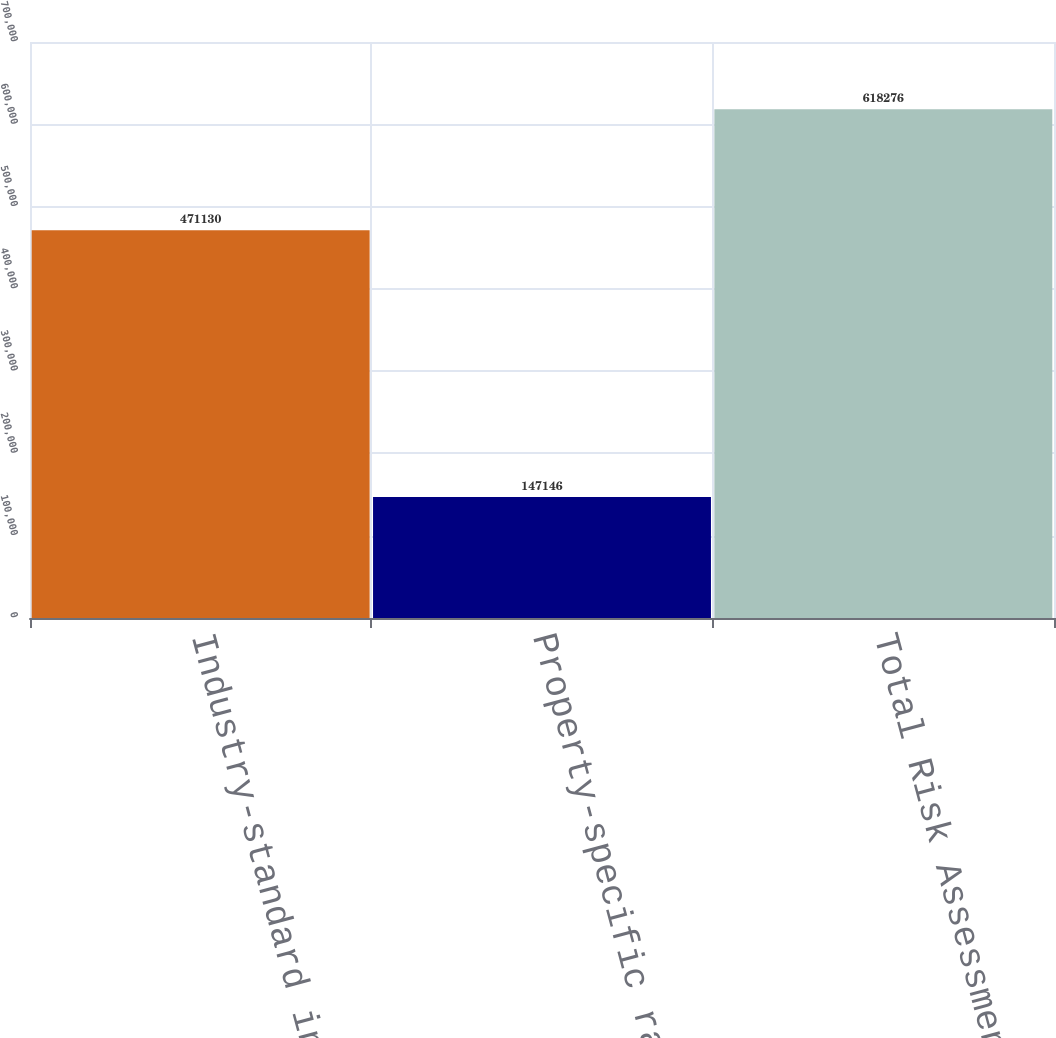Convert chart. <chart><loc_0><loc_0><loc_500><loc_500><bar_chart><fcel>Industry-standard insurance<fcel>Property-specific rating and<fcel>Total Risk Assessment<nl><fcel>471130<fcel>147146<fcel>618276<nl></chart> 